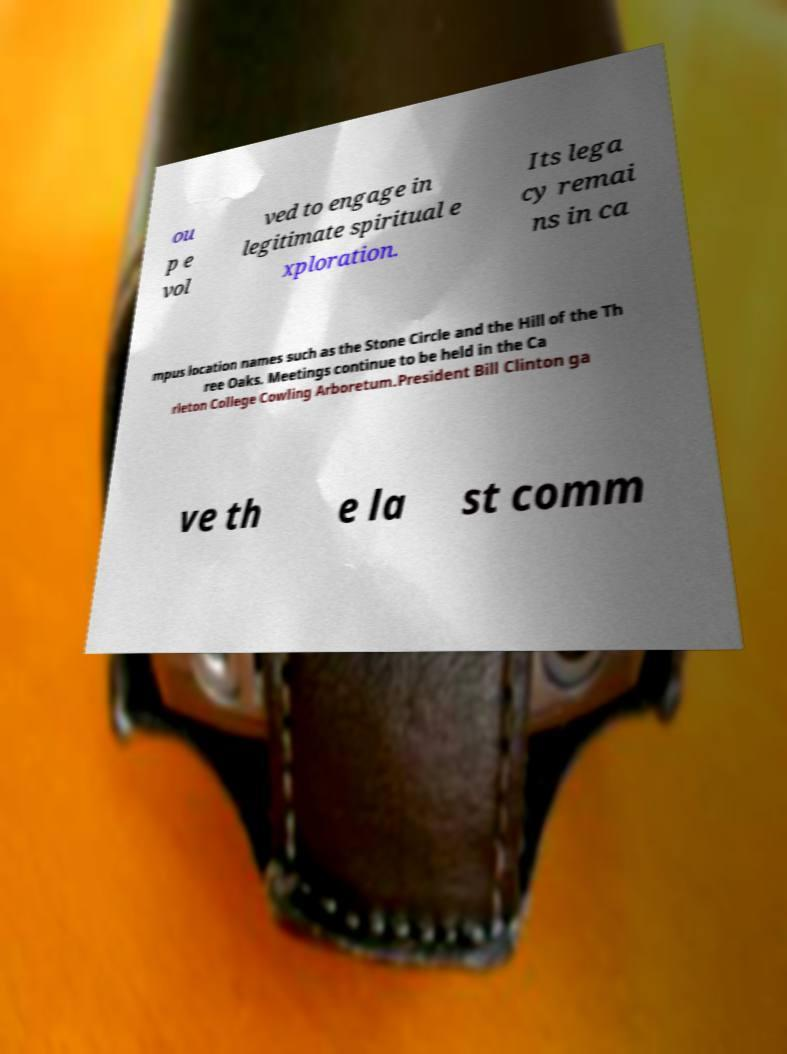There's text embedded in this image that I need extracted. Can you transcribe it verbatim? ou p e vol ved to engage in legitimate spiritual e xploration. Its lega cy remai ns in ca mpus location names such as the Stone Circle and the Hill of the Th ree Oaks. Meetings continue to be held in the Ca rleton College Cowling Arboretum.President Bill Clinton ga ve th e la st comm 